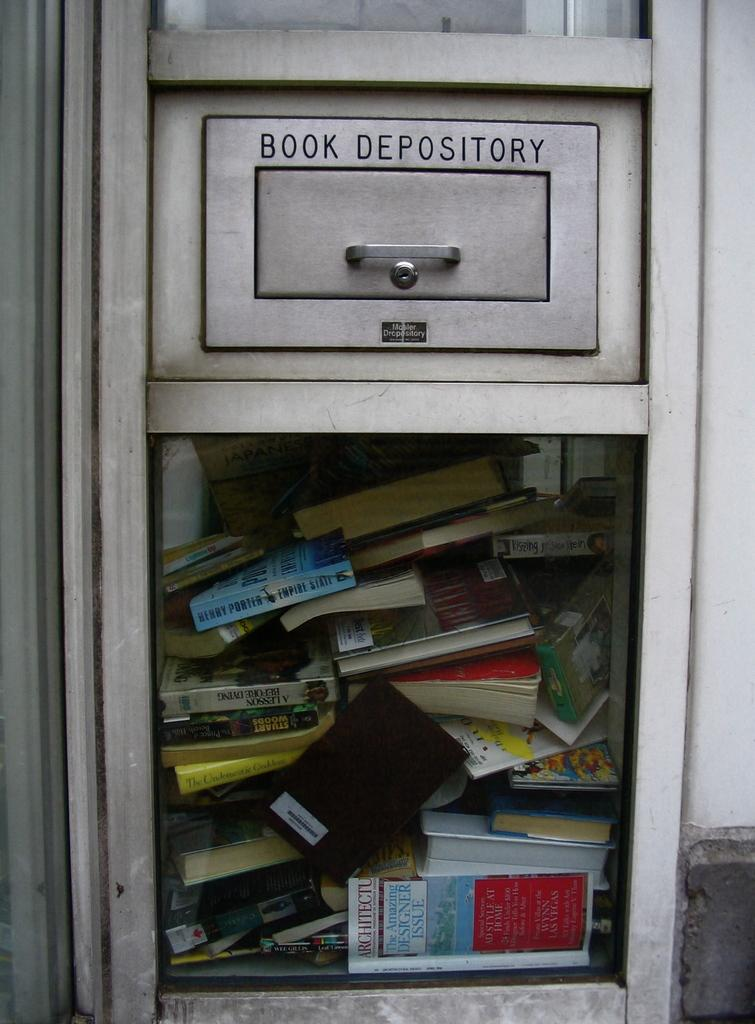<image>
Summarize the visual content of the image. A book depository is full of different types of books. 